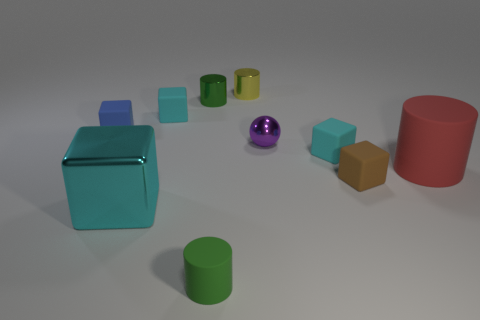Are there any other things that are the same shape as the tiny purple object?
Make the answer very short. No. Is there a small cube of the same color as the large metallic block?
Keep it short and to the point. Yes. Is the big thing behind the big metal cube made of the same material as the green cylinder that is behind the blue rubber block?
Provide a succinct answer. No. There is a matte cylinder that is left of the red rubber cylinder; what is its size?
Your response must be concise. Small. How big is the yellow cylinder?
Offer a very short reply. Small. There is a cyan cube that is in front of the red cylinder that is in front of the small cyan rubber object behind the blue thing; what is its size?
Make the answer very short. Large. Is there a cyan thing made of the same material as the purple thing?
Your response must be concise. Yes. What is the shape of the small purple thing?
Ensure brevity in your answer.  Sphere. What color is the cube that is the same material as the purple object?
Give a very brief answer. Cyan. What number of green things are either tiny metal cylinders or tiny things?
Ensure brevity in your answer.  2. 